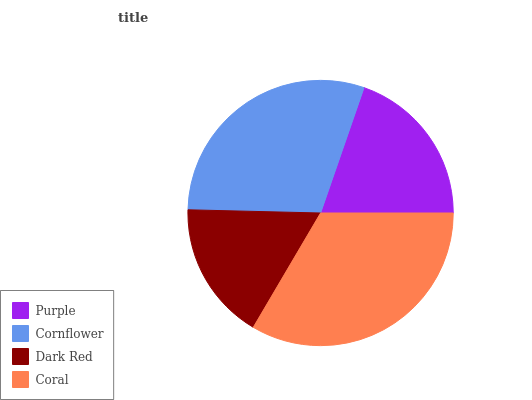Is Dark Red the minimum?
Answer yes or no. Yes. Is Coral the maximum?
Answer yes or no. Yes. Is Cornflower the minimum?
Answer yes or no. No. Is Cornflower the maximum?
Answer yes or no. No. Is Cornflower greater than Purple?
Answer yes or no. Yes. Is Purple less than Cornflower?
Answer yes or no. Yes. Is Purple greater than Cornflower?
Answer yes or no. No. Is Cornflower less than Purple?
Answer yes or no. No. Is Cornflower the high median?
Answer yes or no. Yes. Is Purple the low median?
Answer yes or no. Yes. Is Purple the high median?
Answer yes or no. No. Is Cornflower the low median?
Answer yes or no. No. 